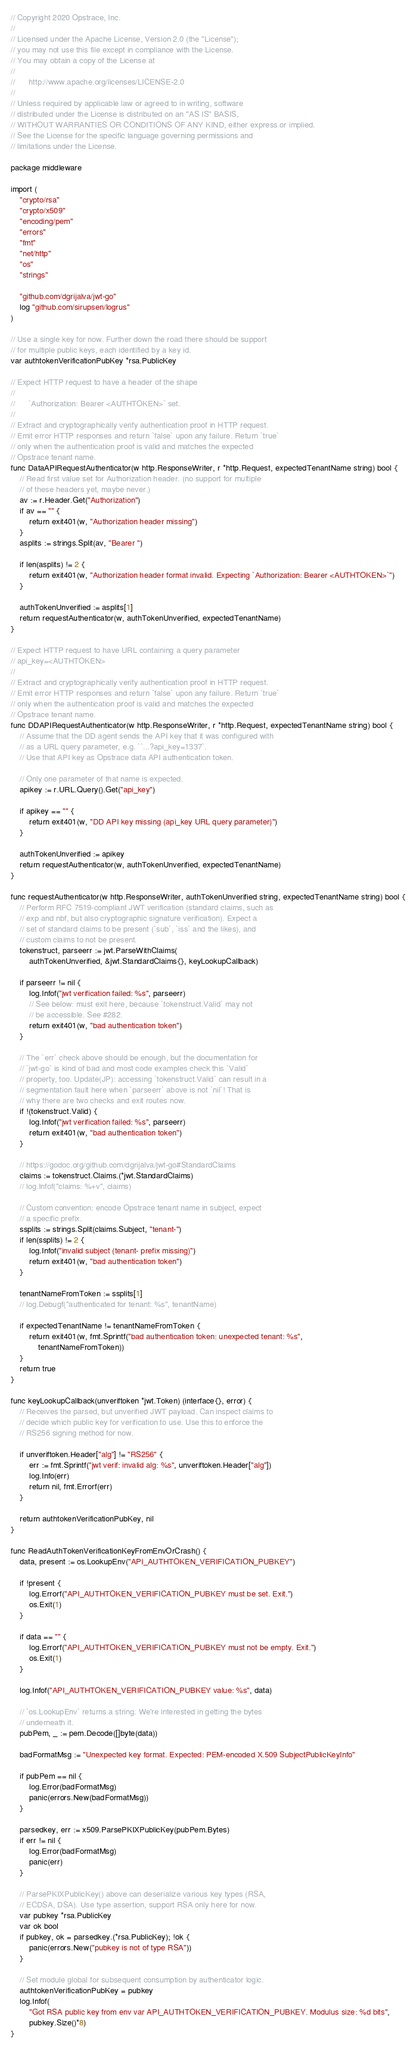Convert code to text. <code><loc_0><loc_0><loc_500><loc_500><_Go_>// Copyright 2020 Opstrace, Inc.
//
// Licensed under the Apache License, Version 2.0 (the "License");
// you may not use this file except in compliance with the License.
// You may obtain a copy of the License at
//
//      http://www.apache.org/licenses/LICENSE-2.0
//
// Unless required by applicable law or agreed to in writing, software
// distributed under the License is distributed on an "AS IS" BASIS,
// WITHOUT WARRANTIES OR CONDITIONS OF ANY KIND, either express or implied.
// See the License for the specific language governing permissions and
// limitations under the License.

package middleware

import (
	"crypto/rsa"
	"crypto/x509"
	"encoding/pem"
	"errors"
	"fmt"
	"net/http"
	"os"
	"strings"

	"github.com/dgrijalva/jwt-go"
	log "github.com/sirupsen/logrus"
)

// Use a single key for now. Further down the road there should be support
// for multiple public keys, each identified by a key id.
var authtokenVerificationPubKey *rsa.PublicKey

// Expect HTTP request to have a header of the shape
//
//      `Authorization: Bearer <AUTHTOKEN>` set.
//
// Extract and cryptographically verify authentication proof in HTTP request.
// Emit error HTTP responses and return `false` upon any failure. Return `true`
// only when the authentication proof is valid and matches the expected
// Opstrace tenant name.
func DataAPIRequestAuthenticator(w http.ResponseWriter, r *http.Request, expectedTenantName string) bool {
	// Read first value set for Authorization header. (no support for multiple
	// of these headers yet, maybe never.)
	av := r.Header.Get("Authorization")
	if av == "" {
		return exit401(w, "Authorization header missing")
	}
	asplits := strings.Split(av, "Bearer ")

	if len(asplits) != 2 {
		return exit401(w, "Authorization header format invalid. Expecting `Authorization: Bearer <AUTHTOKEN>`")
	}

	authTokenUnverified := asplits[1]
	return requestAuthenticator(w, authTokenUnverified, expectedTenantName)
}

// Expect HTTP request to have URL containing a query parameter
// api_key=<AUTHTOKEN>
//
// Extract and cryptographically verify authentication proof in HTTP request.
// Emit error HTTP responses and return `false` upon any failure. Return `true`
// only when the authentication proof is valid and matches the expected
// Opstrace tenant name.
func DDAPIRequestAuthenticator(w http.ResponseWriter, r *http.Request, expectedTenantName string) bool {
	// Assume that the DD agent sends the API key that it was configured with
	// as a URL query parameter, e.g. ``...?api_key=1337`.
	// Use that API key as Opstrace data API authentication token.

	// Only one parameter of that name is expected.
	apikey := r.URL.Query().Get("api_key")

	if apikey == "" {
		return exit401(w, "DD API key missing (api_key URL query parameter)")
	}

	authTokenUnverified := apikey
	return requestAuthenticator(w, authTokenUnverified, expectedTenantName)
}

func requestAuthenticator(w http.ResponseWriter, authTokenUnverified string, expectedTenantName string) bool {
	// Perform RFC 7519-compliant JWT verification (standard claims, such as
	// exp and nbf, but also cryptographic signature verification). Expect a
	// set of standard claims to be present (`sub`, `iss` and the likes), and
	// custom claims to not be present.
	tokenstruct, parseerr := jwt.ParseWithClaims(
		authTokenUnverified, &jwt.StandardClaims{}, keyLookupCallback)

	if parseerr != nil {
		log.Infof("jwt verification failed: %s", parseerr)
		// See below: must exit here, because `tokenstruct.Valid` may not
		// be accessible. See #282.
		return exit401(w, "bad authentication token")
	}

	// The `err` check above should be enough, but the documentation for
	// `jwt-go` is kind of bad and most code examples check this `Valid`
	// property, too. Update(JP): accessing `tokenstruct.Valid` can result in a
	// segmentation fault here when `parseerr` above is not `nil`! That is
	// why there are two checks and exit routes now.
	if !(tokenstruct.Valid) {
		log.Infof("jwt verification failed: %s", parseerr)
		return exit401(w, "bad authentication token")
	}

	// https://godoc.org/github.com/dgrijalva/jwt-go#StandardClaims
	claims := tokenstruct.Claims.(*jwt.StandardClaims)
	// log.Infof("claims: %+v", claims)

	// Custom convention: encode Opstrace tenant name in subject, expect
	// a specific prefix.
	ssplits := strings.Split(claims.Subject, "tenant-")
	if len(ssplits) != 2 {
		log.Infof("invalid subject (tenant- prefix missing)")
		return exit401(w, "bad authentication token")
	}

	tenantNameFromToken := ssplits[1]
	// log.Debugf("authenticated for tenant: %s", tenantName)

	if expectedTenantName != tenantNameFromToken {
		return exit401(w, fmt.Sprintf("bad authentication token: unexpected tenant: %s",
			tenantNameFromToken))
	}
	return true
}

func keyLookupCallback(unveriftoken *jwt.Token) (interface{}, error) {
	// Receives the parsed, but unverified JWT payload. Can inspect claims to
	// decide which public key for verification to use. Use this to enforce the
	// RS256 signing method for now.

	if unveriftoken.Header["alg"] != "RS256" {
		err := fmt.Sprintf("jwt verif: invalid alg: %s", unveriftoken.Header["alg"])
		log.Info(err)
		return nil, fmt.Errorf(err)
	}

	return authtokenVerificationPubKey, nil
}

func ReadAuthTokenVerificationKeyFromEnvOrCrash() {
	data, present := os.LookupEnv("API_AUTHTOKEN_VERIFICATION_PUBKEY")

	if !present {
		log.Errorf("API_AUTHTOKEN_VERIFICATION_PUBKEY must be set. Exit.")
		os.Exit(1)
	}

	if data == "" {
		log.Errorf("API_AUTHTOKEN_VERIFICATION_PUBKEY must not be empty. Exit.")
		os.Exit(1)
	}

	log.Infof("API_AUTHTOKEN_VERIFICATION_PUBKEY value: %s", data)

	// `os.LookupEnv` returns a string. We're interested in getting the bytes
	// underneath it.
	pubPem, _ := pem.Decode([]byte(data))

	badFormatMsg := "Unexpected key format. Expected: PEM-encoded X.509 SubjectPublicKeyInfo"

	if pubPem == nil {
		log.Error(badFormatMsg)
		panic(errors.New(badFormatMsg))
	}

	parsedkey, err := x509.ParsePKIXPublicKey(pubPem.Bytes)
	if err != nil {
		log.Error(badFormatMsg)
		panic(err)
	}

	// ParsePKIXPublicKey() above can deserialize various key types (RSA,
	// ECDSA, DSA). Use type assertion, support RSA only here for now.
	var pubkey *rsa.PublicKey
	var ok bool
	if pubkey, ok = parsedkey.(*rsa.PublicKey); !ok {
		panic(errors.New("pubkey is not of type RSA"))
	}

	// Set module global for subsequent consumption by authenticator logic.
	authtokenVerificationPubKey = pubkey
	log.Infof(
		"Got RSA public key from env var API_AUTHTOKEN_VERIFICATION_PUBKEY. Modulus size: %d bits",
		pubkey.Size()*8)
}
</code> 